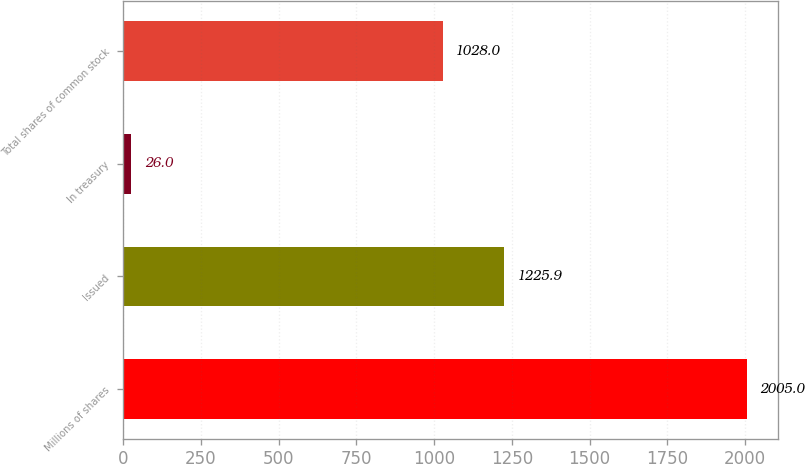<chart> <loc_0><loc_0><loc_500><loc_500><bar_chart><fcel>Millions of shares<fcel>Issued<fcel>In treasury<fcel>Total shares of common stock<nl><fcel>2005<fcel>1225.9<fcel>26<fcel>1028<nl></chart> 